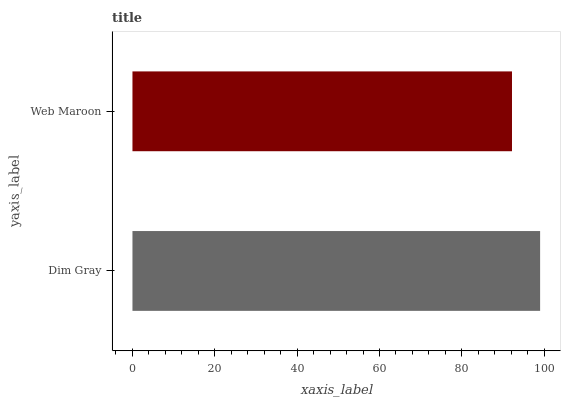Is Web Maroon the minimum?
Answer yes or no. Yes. Is Dim Gray the maximum?
Answer yes or no. Yes. Is Web Maroon the maximum?
Answer yes or no. No. Is Dim Gray greater than Web Maroon?
Answer yes or no. Yes. Is Web Maroon less than Dim Gray?
Answer yes or no. Yes. Is Web Maroon greater than Dim Gray?
Answer yes or no. No. Is Dim Gray less than Web Maroon?
Answer yes or no. No. Is Dim Gray the high median?
Answer yes or no. Yes. Is Web Maroon the low median?
Answer yes or no. Yes. Is Web Maroon the high median?
Answer yes or no. No. Is Dim Gray the low median?
Answer yes or no. No. 